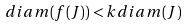<formula> <loc_0><loc_0><loc_500><loc_500>d i a m ( f ( J ) ) < k d i a m ( J )</formula> 